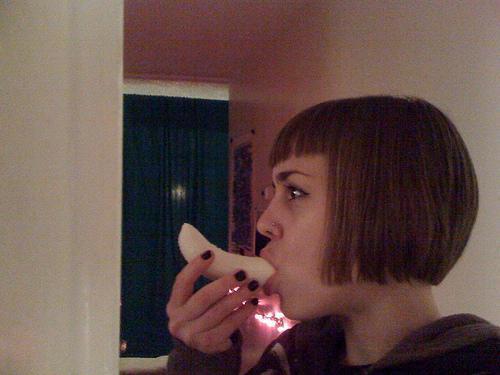Does the description: "The person is behind the banana." accurately reflect the image?
Answer yes or no. No. 